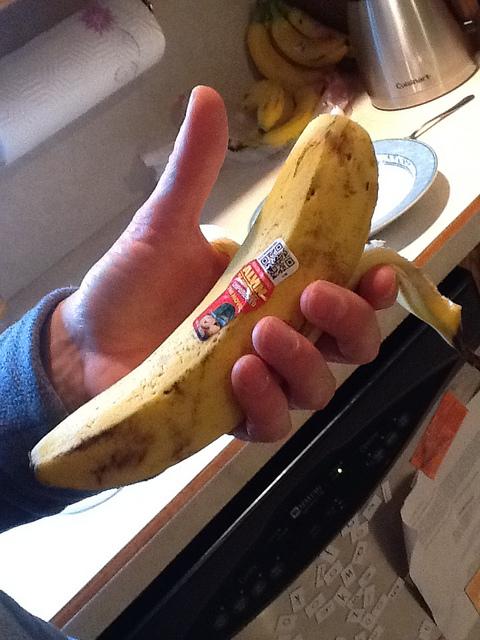What kind of fruit is in the picture?
Quick response, please. Banana. Which hand is holding the banana?
Short answer required. Left. How many bananas is the person holding?
Write a very short answer. 1. 